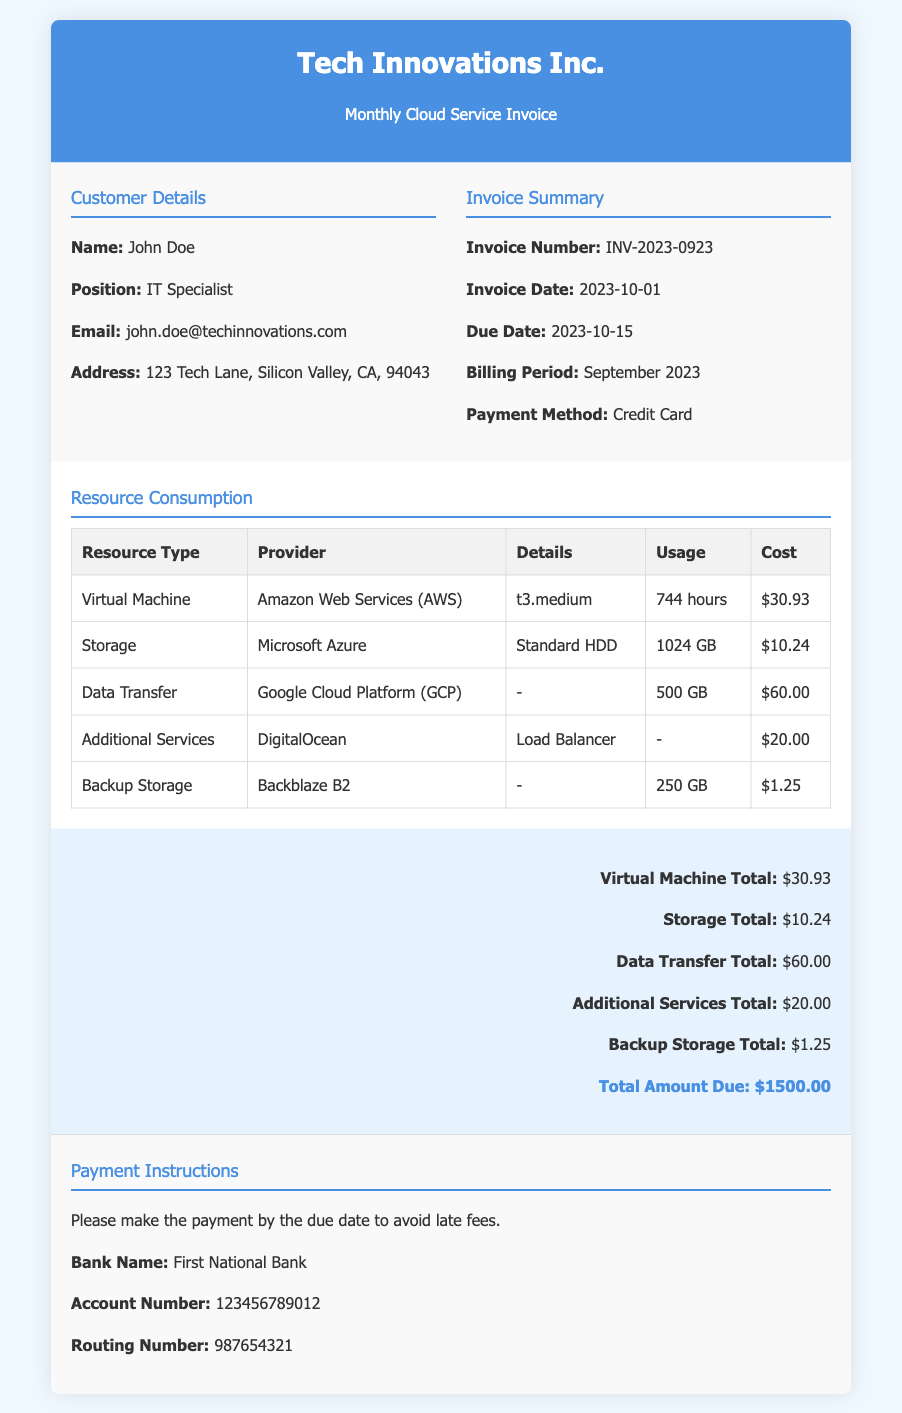What is the invoice number? The invoice number is listed under the invoice summary section of the document.
Answer: INV-2023-0923 Who is the customer? The customer's name is provided in the customer details section of the document.
Answer: John Doe What is the total cost of the virtual machine usage? The total cost is included in the resource consumption table under the virtual machine row.
Answer: $30.93 What is the billing period for this invoice? The billing period is stated in the invoice summary section.
Answer: September 2023 What is the due date for the payment? The due date is found in the invoice summary section of the document.
Answer: 2023-10-15 How many hours was the virtual machine used? The usage hours for the virtual machine is specified in the resource consumption table.
Answer: 744 hours Which payment method is used? The payment method is indicated in the invoice summary section.
Answer: Credit Card What is the usage for backup storage? The usage for backup storage is noted in the resource consumption table.
Answer: 250 GB What is the total amount due? The total amount due is highlighted at the bottom of the document.
Answer: $1500.00 